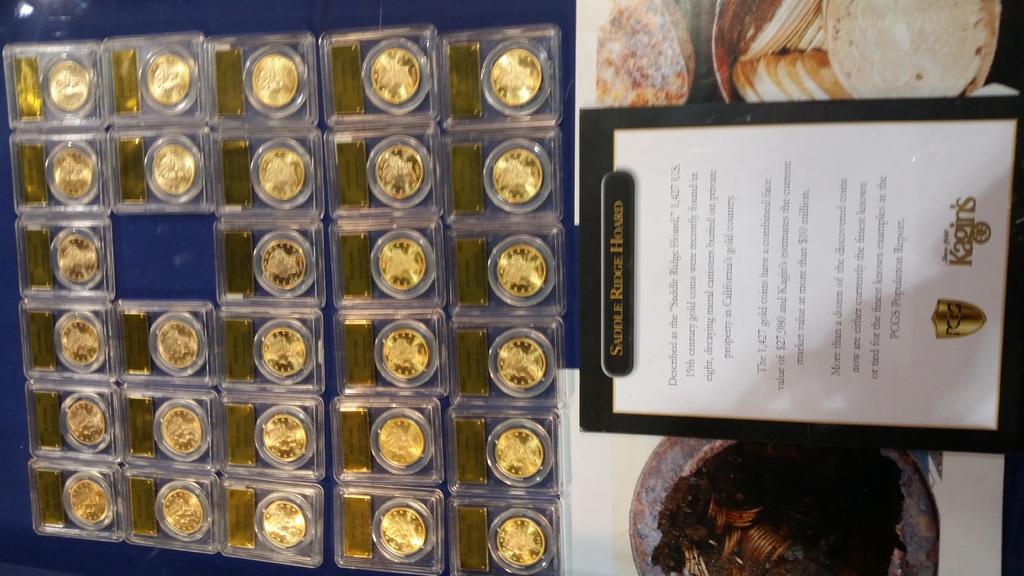What kind of hoard is this?
Your answer should be very brief. Saddle ridge. 